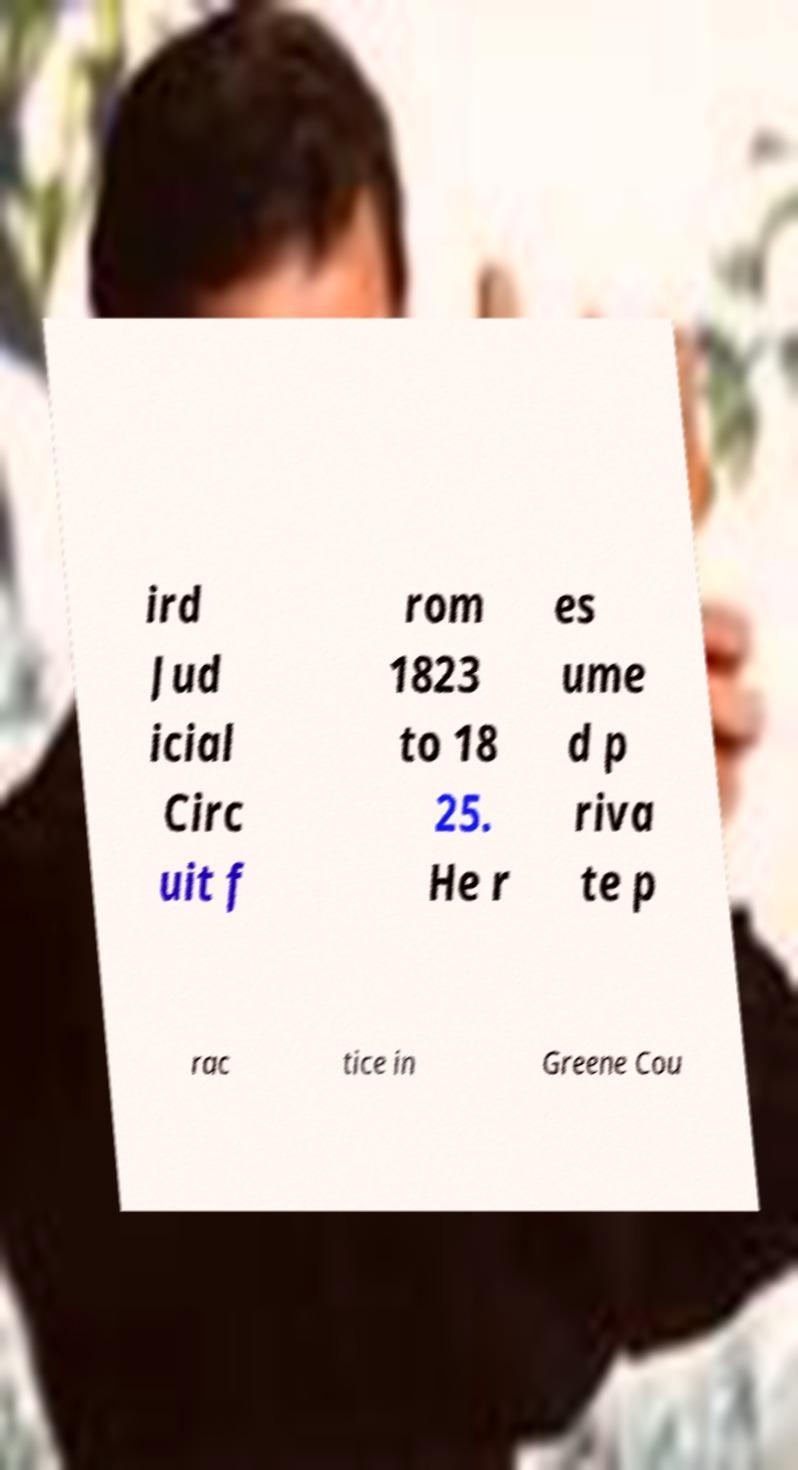I need the written content from this picture converted into text. Can you do that? ird Jud icial Circ uit f rom 1823 to 18 25. He r es ume d p riva te p rac tice in Greene Cou 